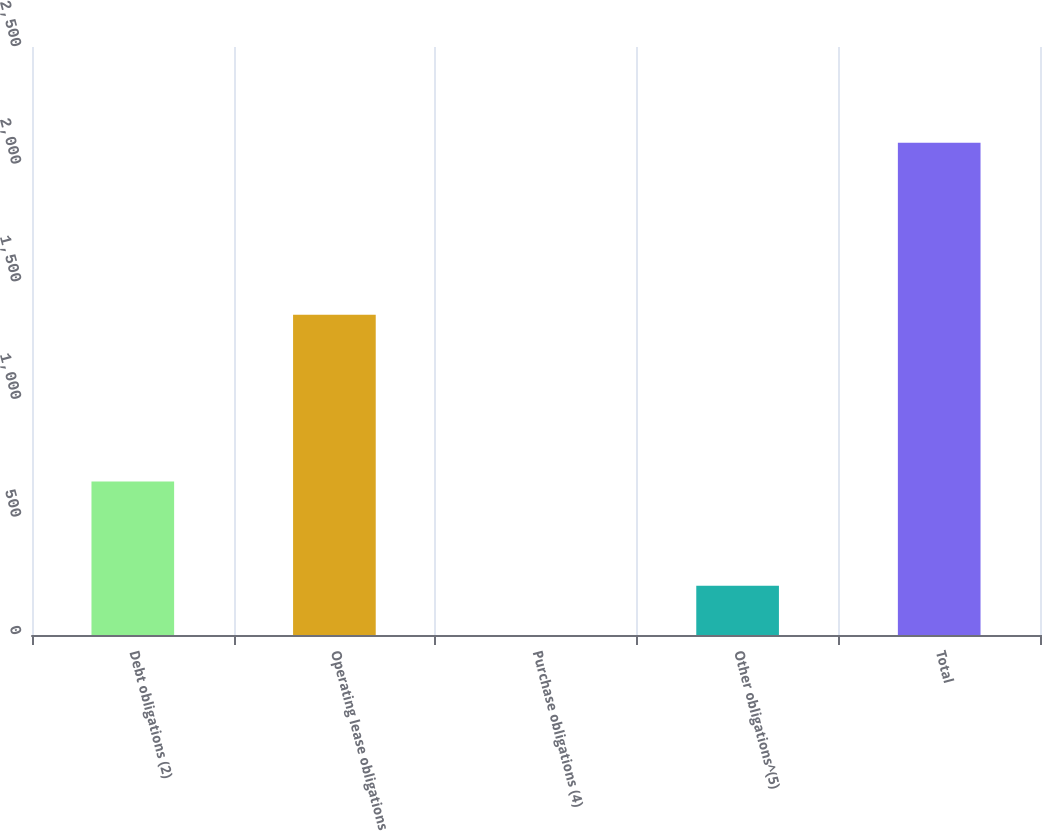<chart> <loc_0><loc_0><loc_500><loc_500><bar_chart><fcel>Debt obligations (2)<fcel>Operating lease obligations<fcel>Purchase obligations (4)<fcel>Other obligations^(5)<fcel>Total<nl><fcel>653.1<fcel>1362.1<fcel>0.5<fcel>209.7<fcel>2092.5<nl></chart> 